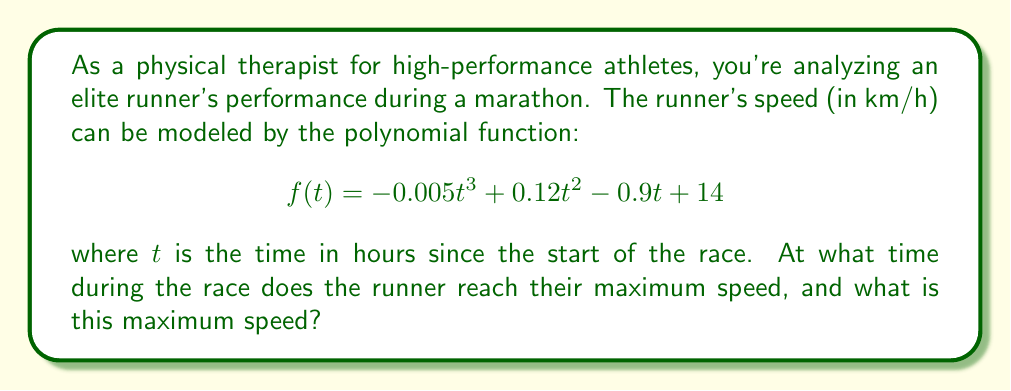Solve this math problem. To find the maximum speed and when it occurs, we need to follow these steps:

1) The maximum speed will occur at a critical point of the function, where the derivative equals zero. Let's find the derivative:

   $$f'(t) = -0.015t^2 + 0.24t - 0.9$$

2) Set the derivative equal to zero and solve for t:

   $$-0.015t^2 + 0.24t - 0.9 = 0$$

3) This is a quadratic equation. We can solve it using the quadratic formula:

   $$t = \frac{-b \pm \sqrt{b^2 - 4ac}}{2a}$$

   where $a = -0.015$, $b = 0.24$, and $c = -0.9$

4) Plugging in these values:

   $$t = \frac{-0.24 \pm \sqrt{0.24^2 - 4(-0.015)(-0.9)}}{2(-0.015)}$$

   $$= \frac{-0.24 \pm \sqrt{0.0576 + 0.054}}{-0.03}$$

   $$= \frac{-0.24 \pm \sqrt{0.1116}}{-0.03}$$

   $$= \frac{-0.24 \pm 0.334}{-0.03}$$

5) This gives us two solutions:

   $$t_1 = \frac{-0.24 + 0.334}{-0.03} = 3.13 \text{ hours}$$
   $$t_2 = \frac{-0.24 - 0.334}{-0.03} = 19.13 \text{ hours}$$

6) Since a marathon typically lasts less than 19 hours, we can discard the second solution. The maximum speed occurs at $t = 3.13$ hours.

7) To find the maximum speed, we plug this value of t back into our original function:

   $$f(3.13) = -0.005(3.13)^3 + 0.12(3.13)^2 - 0.9(3.13) + 14$$

   $$= -0.152 + 1.175 - 2.817 + 14 = 12.206 \text{ km/h}$$

Therefore, the runner reaches their maximum speed of approximately 12.21 km/h at 3.13 hours (or 3 hours and 8 minutes) into the race.
Answer: The runner reaches their maximum speed of 12.21 km/h at 3.13 hours (3 hours and 8 minutes) into the race. 